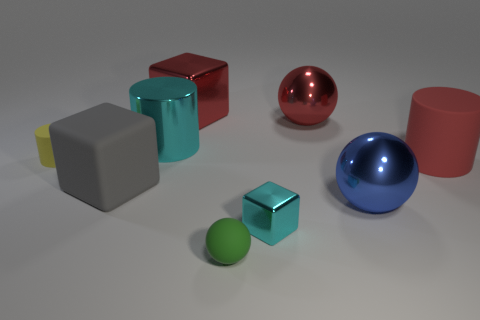Subtract all cubes. How many objects are left? 6 Add 1 large gray things. How many large gray things are left? 2 Add 3 red things. How many red things exist? 6 Subtract 1 red cubes. How many objects are left? 8 Subtract all big red metallic spheres. Subtract all small shiny things. How many objects are left? 7 